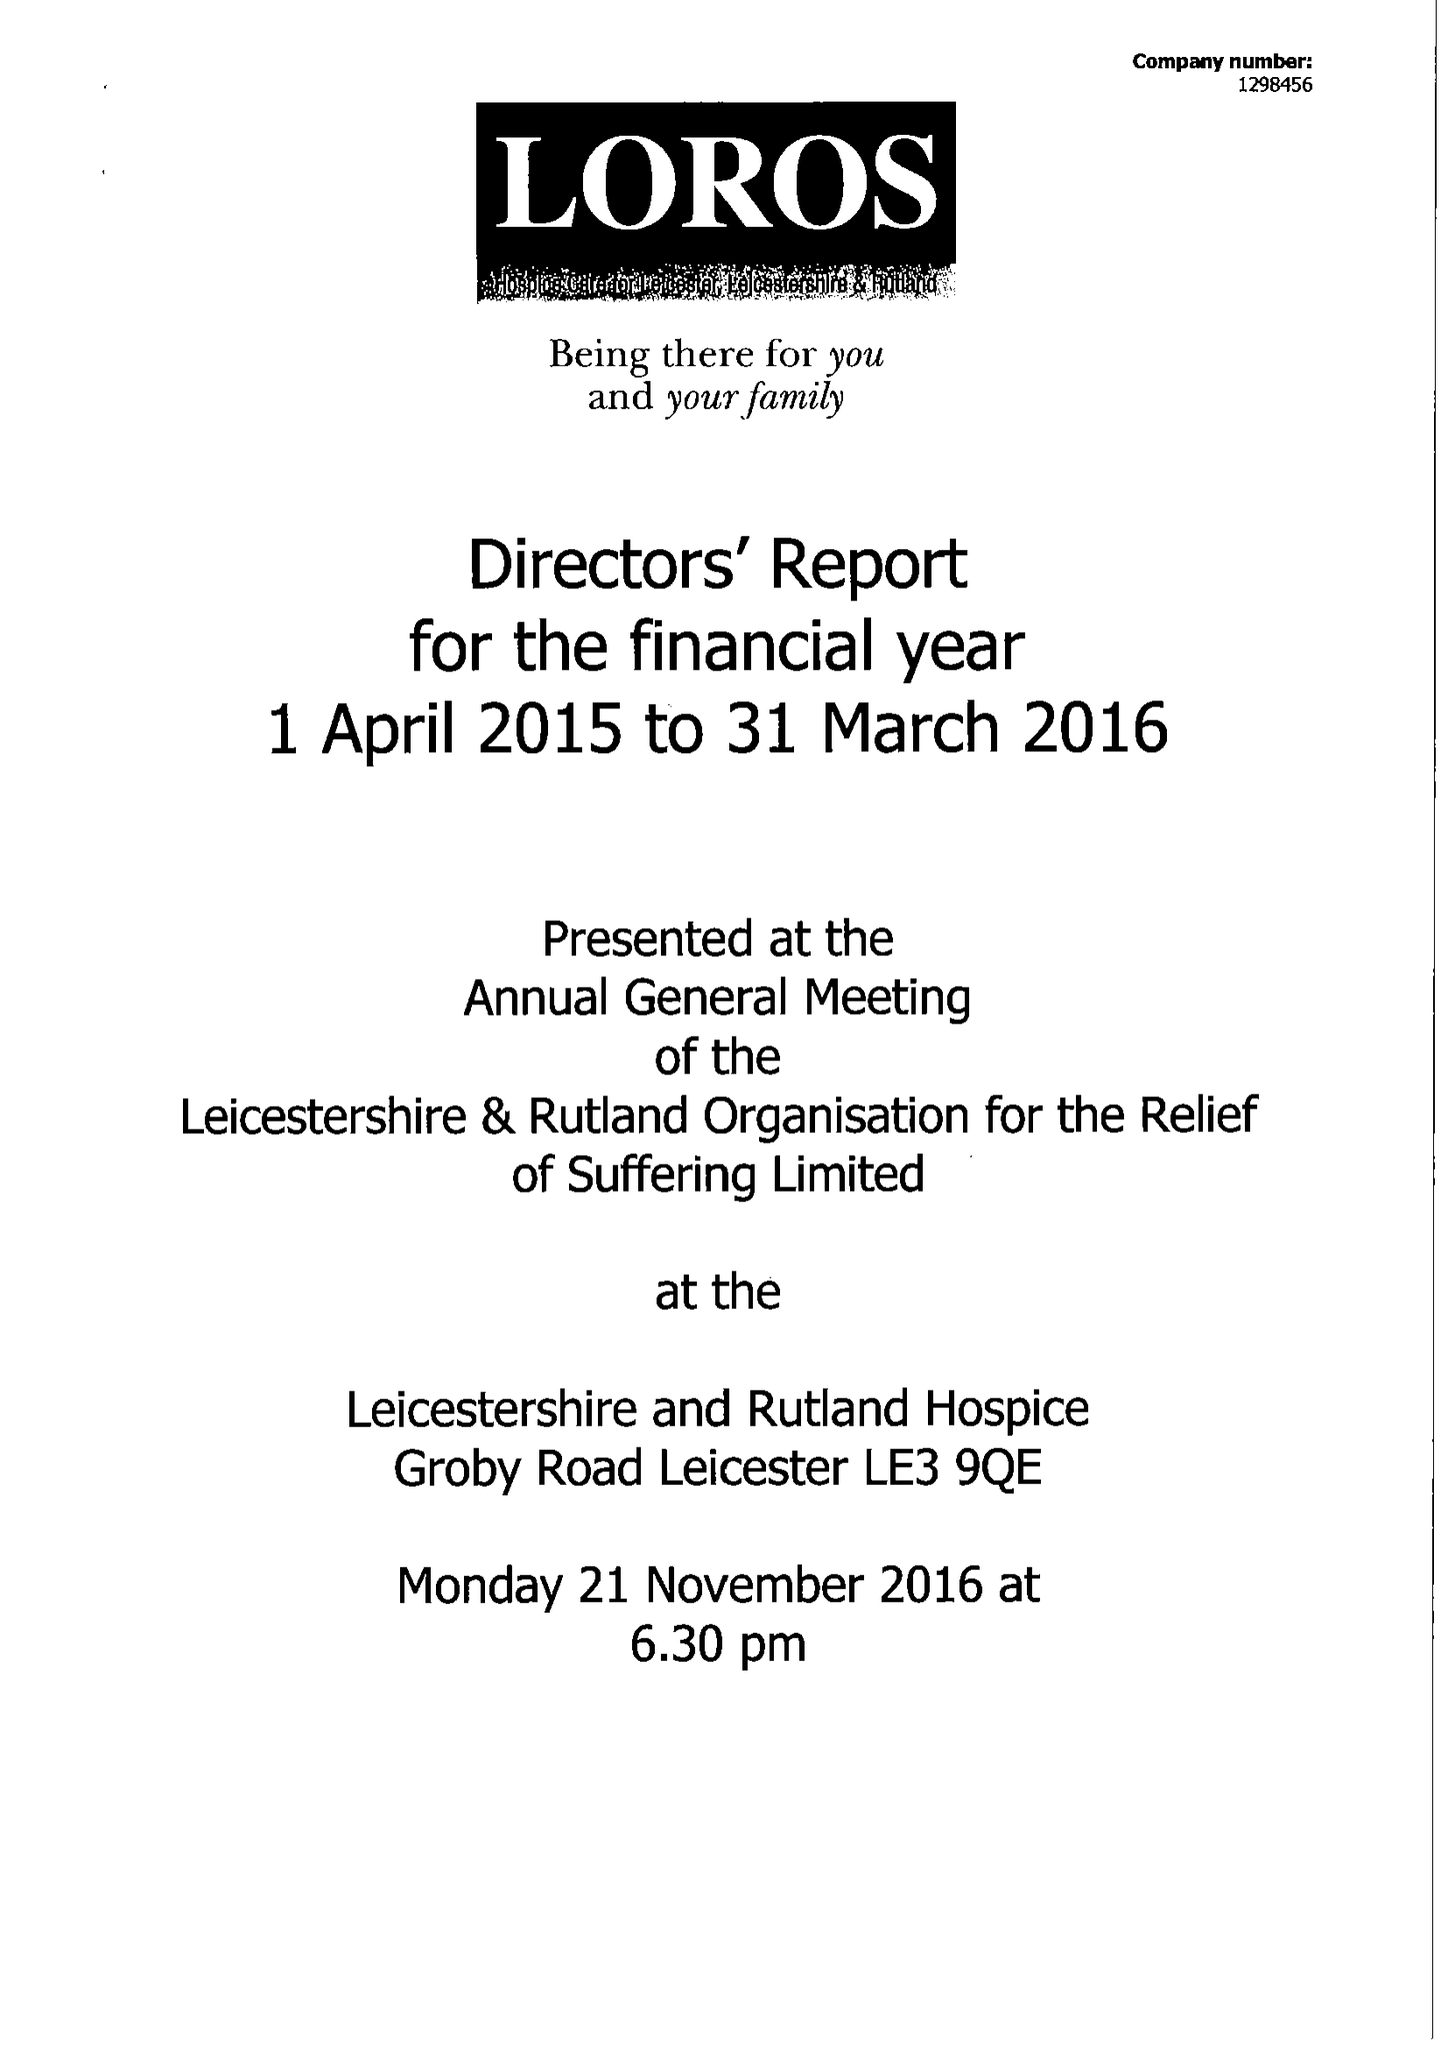What is the value for the charity_number?
Answer the question using a single word or phrase. 506120 